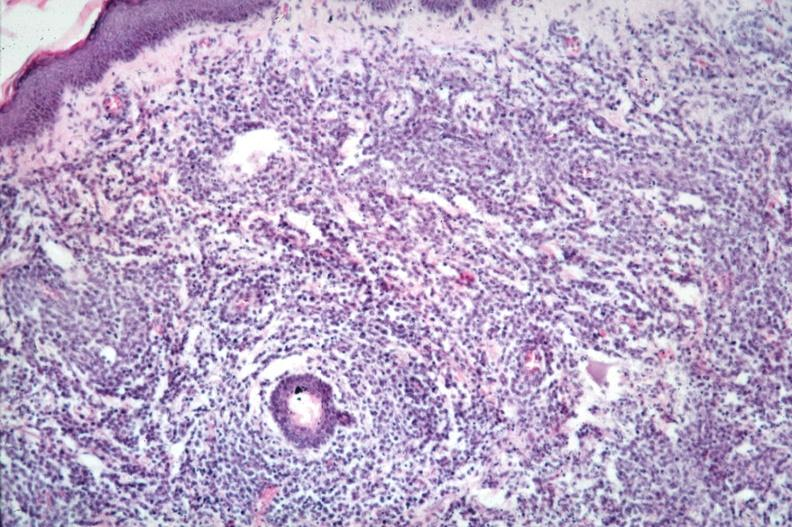where is this?
Answer the question using a single word or phrase. Skin 